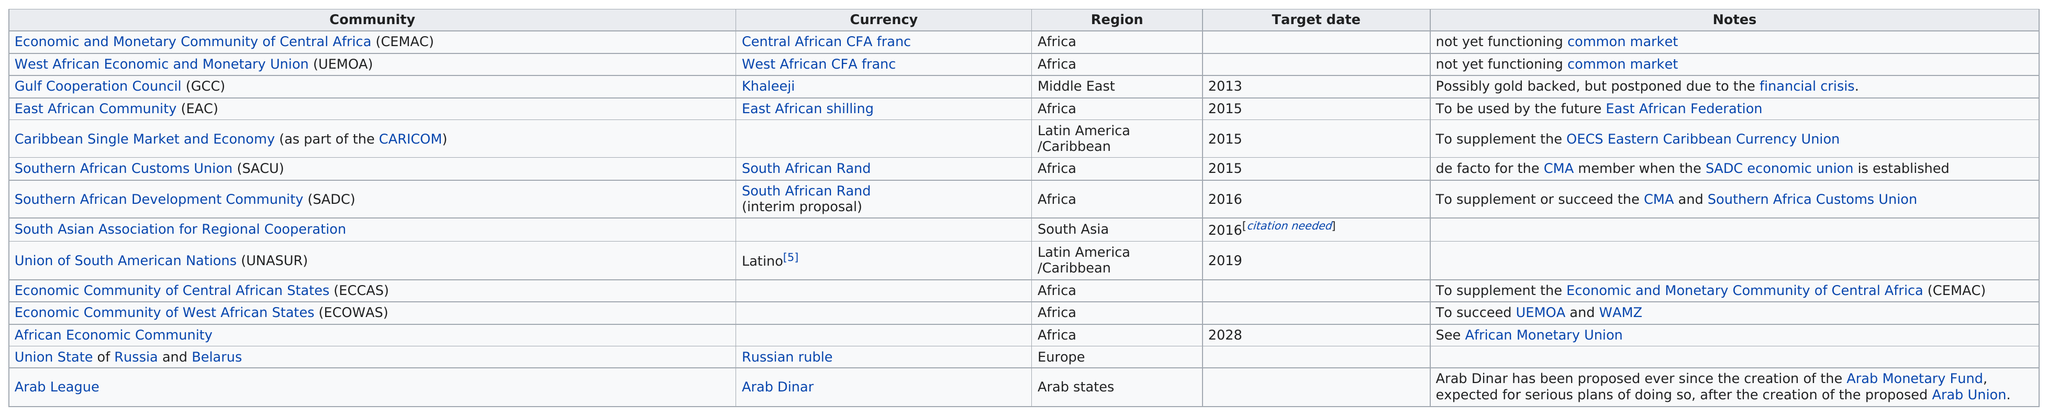Point out several critical features in this image. South Asian Association for Regional Cooperation is the only proposed community in the South Asia region. The African Economic Community is the latest target date among the three economic communities. Eight communities are based in Africa. South Asian Association for Regional Cooperation is the only community in South Asia. Out of the proposed communities, how many would use the East African Shilling currency? 